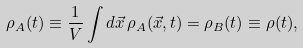Convert formula to latex. <formula><loc_0><loc_0><loc_500><loc_500>\rho _ { A } ( t ) \equiv \frac { 1 } { V } \int d \vec { x } \, \rho _ { A } ( \vec { x } , t ) = \rho _ { B } ( t ) \equiv \rho ( t ) ,</formula> 